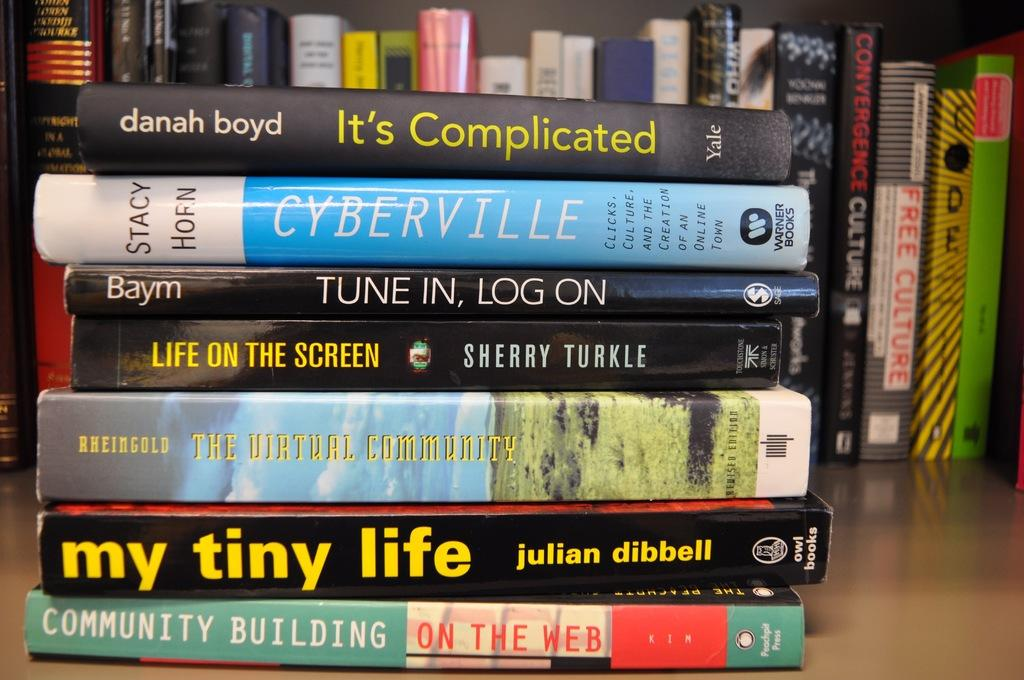Provide a one-sentence caption for the provided image. Different books stacked on top of each other, top book says Danah Boyd Its Complicated Yale. 